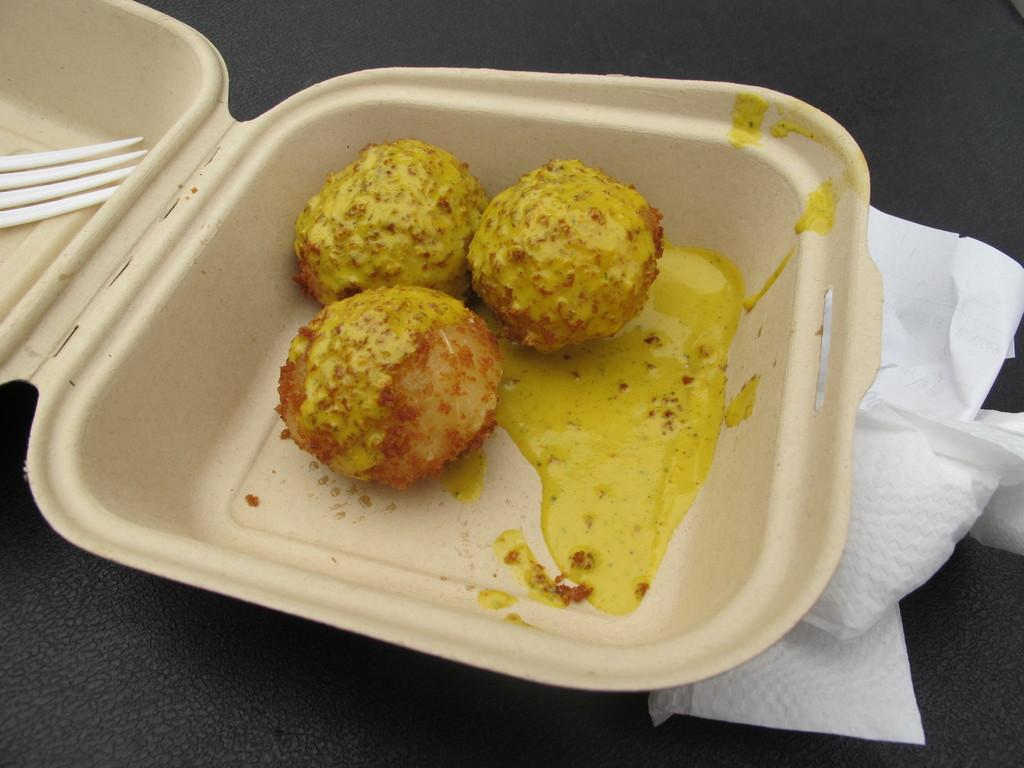What object is present in the image that can hold items? There is a box in the image that can hold items. What type of food item can be seen inside the box? There is a food item inside the box. What utensil is present inside the box? There is a fork inside the box. What is located below the box in the image? There are tissue papers below the box. What is the color of the surface on which the box is placed? The box is on a black surface. Can you see a trail of coal leading to the box in the image? There is no trail of coal present in the image. 